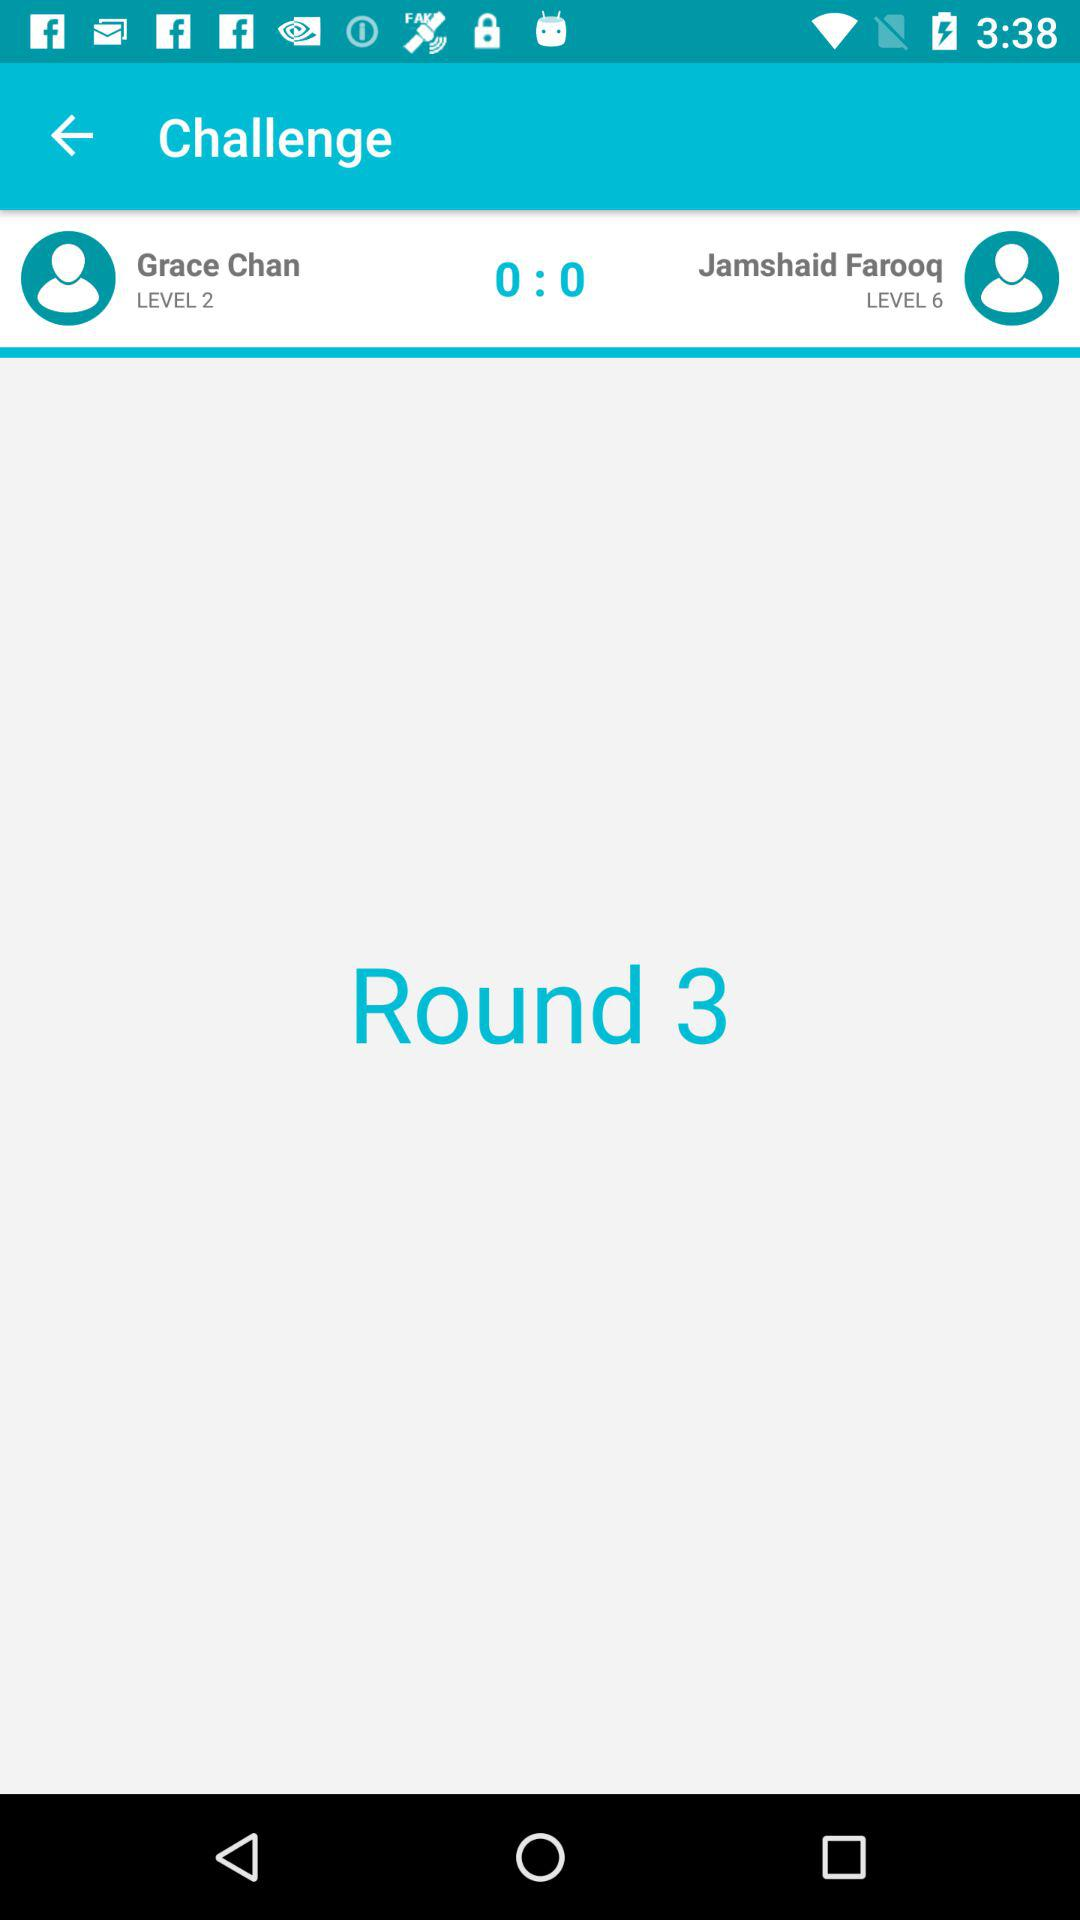What level is Grace Chan at? Grace Chan is at level 2. 